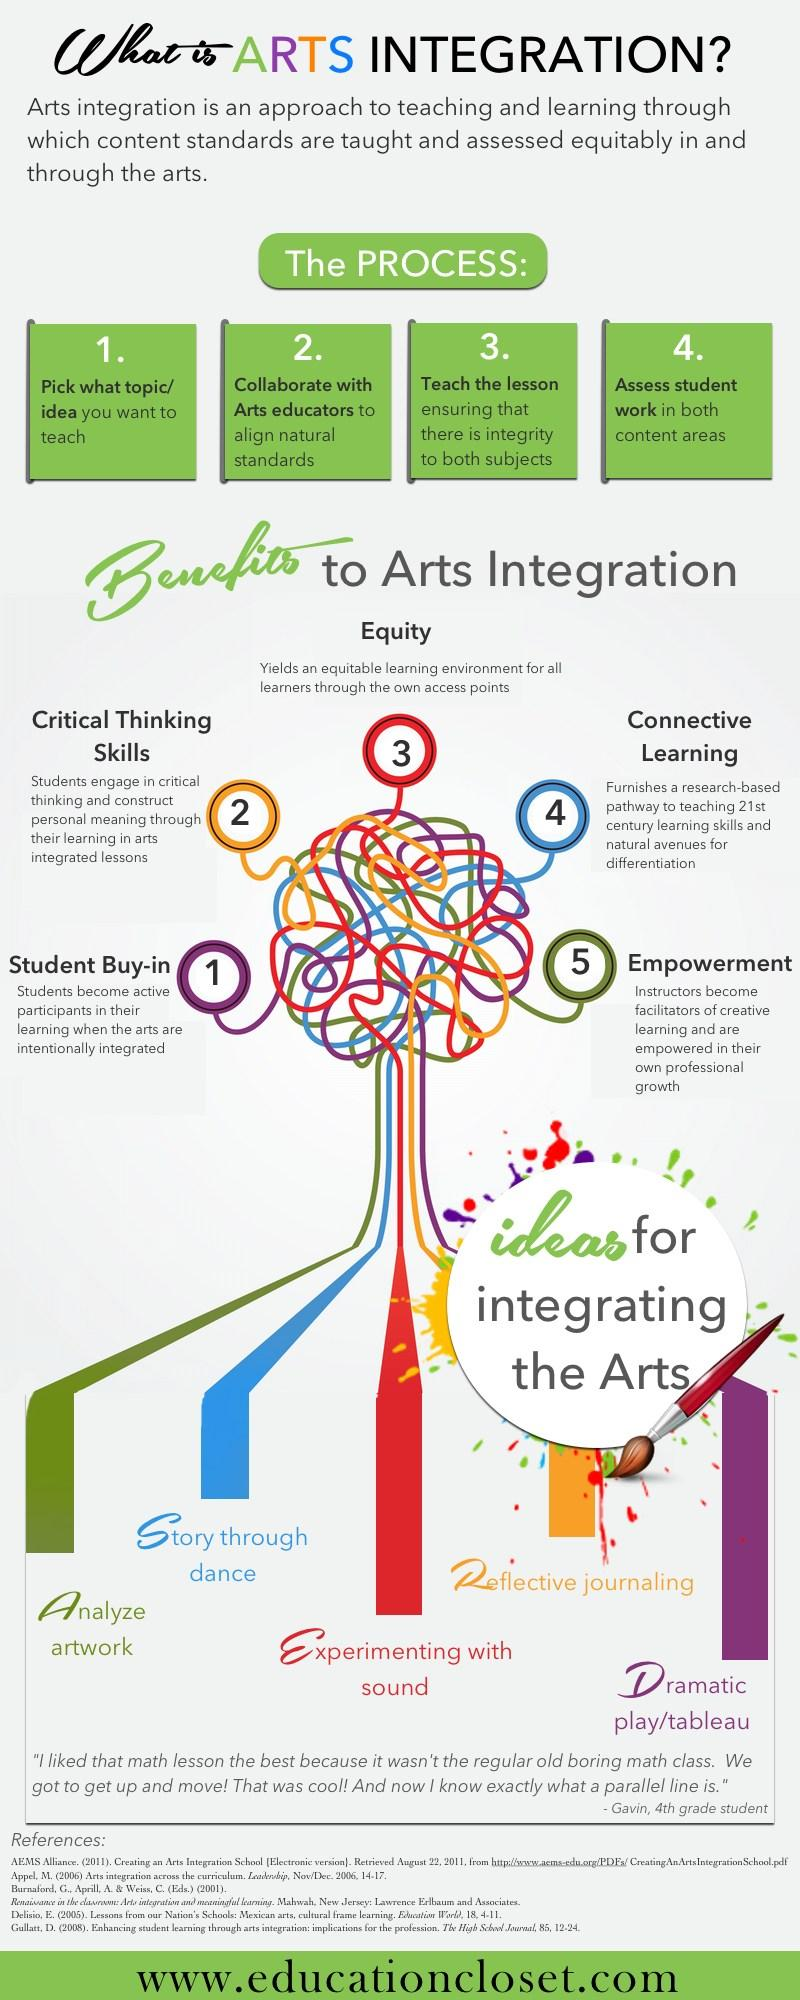Mention a couple of crucial points in this snapshot. Dramatic play/tableau is an idea or method that allows students to participate actively in the learning process. Educators benefit from analyzing artwork by gaining empowerment. Students derive significant benefits from learning stories through dance, as connected learning provides a holistic and engaging approach to acquiring knowledge and skills. The idea of experimenting with sound creates an equal learning atmosphere for all learners. Reflective journaling enhances critical thinking skills in students. 